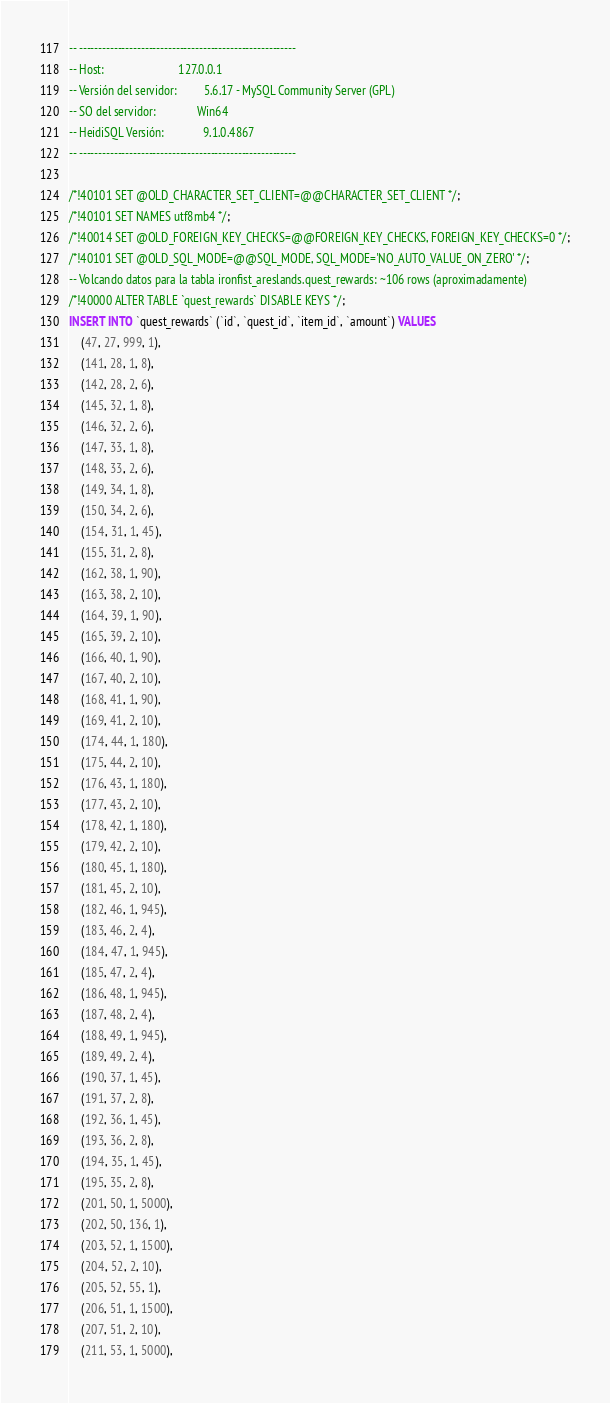<code> <loc_0><loc_0><loc_500><loc_500><_SQL_>-- --------------------------------------------------------
-- Host:                         127.0.0.1
-- Versión del servidor:         5.6.17 - MySQL Community Server (GPL)
-- SO del servidor:              Win64
-- HeidiSQL Versión:             9.1.0.4867
-- --------------------------------------------------------

/*!40101 SET @OLD_CHARACTER_SET_CLIENT=@@CHARACTER_SET_CLIENT */;
/*!40101 SET NAMES utf8mb4 */;
/*!40014 SET @OLD_FOREIGN_KEY_CHECKS=@@FOREIGN_KEY_CHECKS, FOREIGN_KEY_CHECKS=0 */;
/*!40101 SET @OLD_SQL_MODE=@@SQL_MODE, SQL_MODE='NO_AUTO_VALUE_ON_ZERO' */;
-- Volcando datos para la tabla ironfist_areslands.quest_rewards: ~106 rows (aproximadamente)
/*!40000 ALTER TABLE `quest_rewards` DISABLE KEYS */;
INSERT INTO `quest_rewards` (`id`, `quest_id`, `item_id`, `amount`) VALUES
	(47, 27, 999, 1),
	(141, 28, 1, 8),
	(142, 28, 2, 6),
	(145, 32, 1, 8),
	(146, 32, 2, 6),
	(147, 33, 1, 8),
	(148, 33, 2, 6),
	(149, 34, 1, 8),
	(150, 34, 2, 6),
	(154, 31, 1, 45),
	(155, 31, 2, 8),
	(162, 38, 1, 90),
	(163, 38, 2, 10),
	(164, 39, 1, 90),
	(165, 39, 2, 10),
	(166, 40, 1, 90),
	(167, 40, 2, 10),
	(168, 41, 1, 90),
	(169, 41, 2, 10),
	(174, 44, 1, 180),
	(175, 44, 2, 10),
	(176, 43, 1, 180),
	(177, 43, 2, 10),
	(178, 42, 1, 180),
	(179, 42, 2, 10),
	(180, 45, 1, 180),
	(181, 45, 2, 10),
	(182, 46, 1, 945),
	(183, 46, 2, 4),
	(184, 47, 1, 945),
	(185, 47, 2, 4),
	(186, 48, 1, 945),
	(187, 48, 2, 4),
	(188, 49, 1, 945),
	(189, 49, 2, 4),
	(190, 37, 1, 45),
	(191, 37, 2, 8),
	(192, 36, 1, 45),
	(193, 36, 2, 8),
	(194, 35, 1, 45),
	(195, 35, 2, 8),
	(201, 50, 1, 5000),
	(202, 50, 136, 1),
	(203, 52, 1, 1500),
	(204, 52, 2, 10),
	(205, 52, 55, 1),
	(206, 51, 1, 1500),
	(207, 51, 2, 10),
	(211, 53, 1, 5000),</code> 